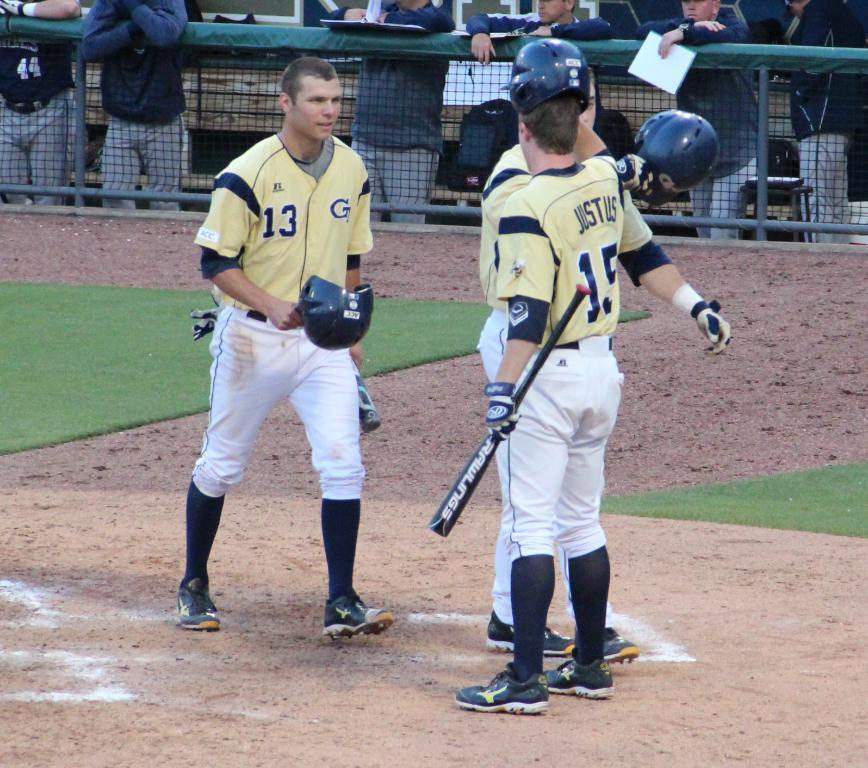<image>
Describe the image concisely. Player 13 is having an argue with player 15. 